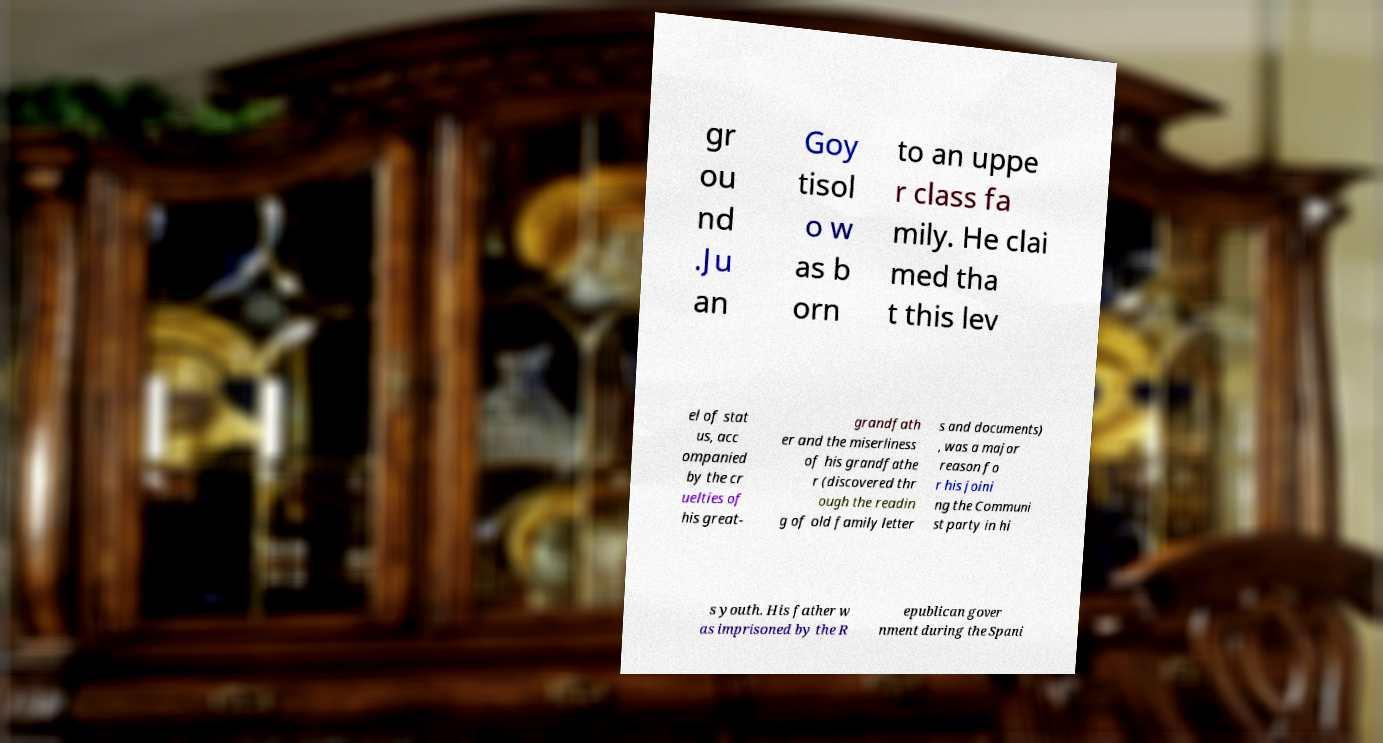Please read and relay the text visible in this image. What does it say? gr ou nd .Ju an Goy tisol o w as b orn to an uppe r class fa mily. He clai med tha t this lev el of stat us, acc ompanied by the cr uelties of his great- grandfath er and the miserliness of his grandfathe r (discovered thr ough the readin g of old family letter s and documents) , was a major reason fo r his joini ng the Communi st party in hi s youth. His father w as imprisoned by the R epublican gover nment during the Spani 